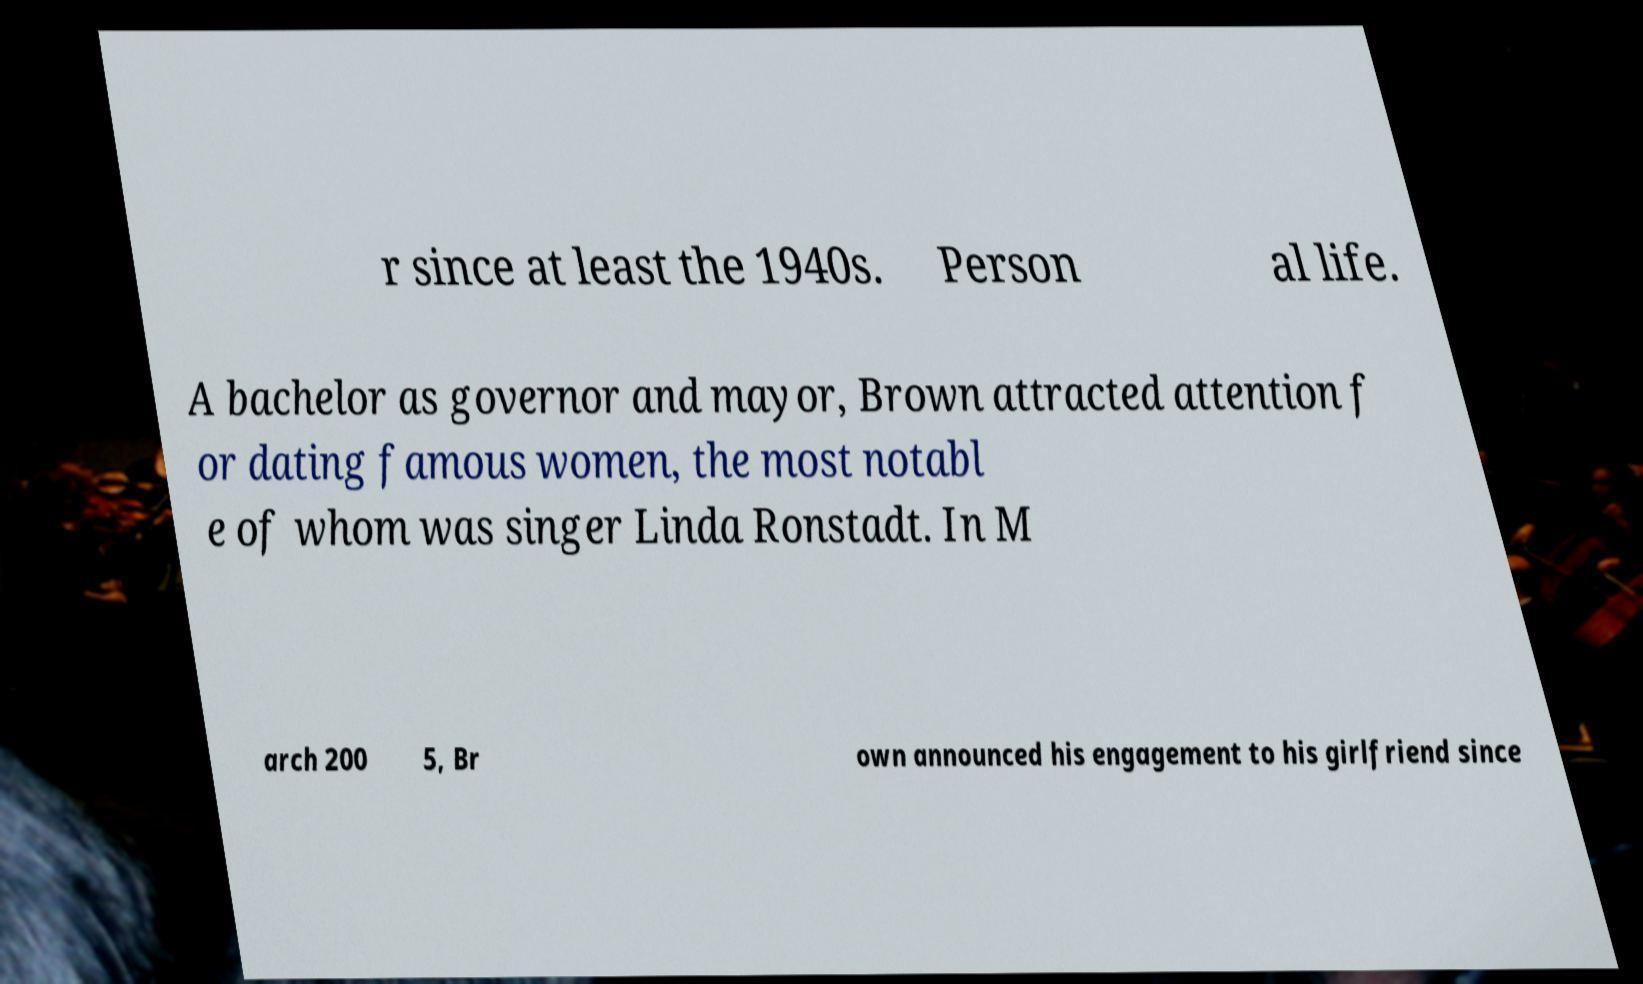I need the written content from this picture converted into text. Can you do that? r since at least the 1940s. Person al life. A bachelor as governor and mayor, Brown attracted attention f or dating famous women, the most notabl e of whom was singer Linda Ronstadt. In M arch 200 5, Br own announced his engagement to his girlfriend since 